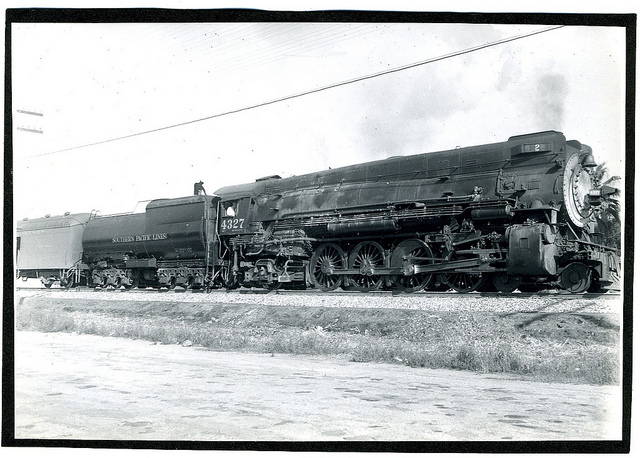Can you tell me anything about the type of train in the picture? This is a steam locomotive, characterized by its large drive wheels and the steam-producing smokestack. It's a classic example of the powerful engines that drove the expansion of railroads and the transport of goods and passengers across countries. Could such a train still be operational today? While steam trains like this one are no longer used for commercial transportation, they are often preserved and operated on heritage railways for educational and historical purposes, allowing enthusiasts and tourists to experience a bygone era of rail travel. 